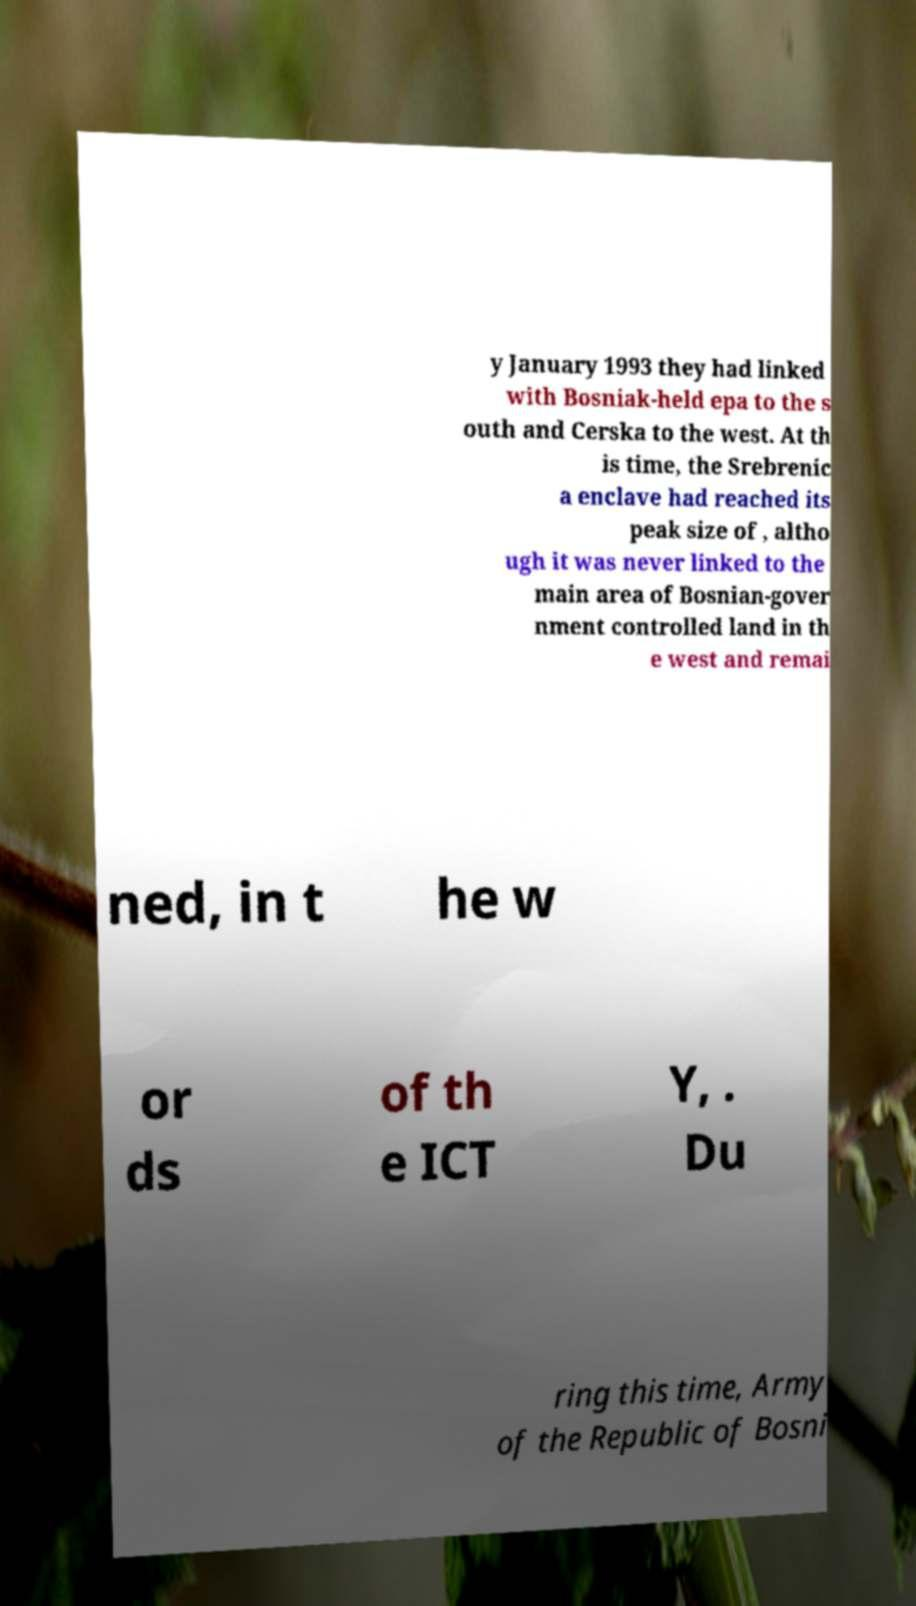Could you extract and type out the text from this image? y January 1993 they had linked with Bosniak-held epa to the s outh and Cerska to the west. At th is time, the Srebrenic a enclave had reached its peak size of , altho ugh it was never linked to the main area of Bosnian-gover nment controlled land in th e west and remai ned, in t he w or ds of th e ICT Y, . Du ring this time, Army of the Republic of Bosni 